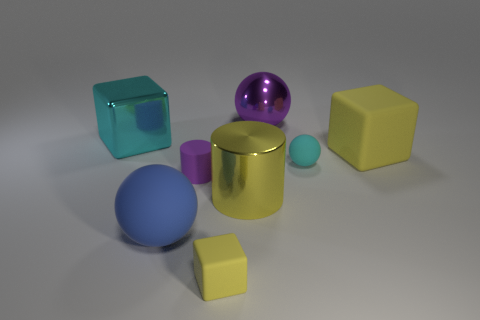How many objects are rubber cylinders or tiny yellow things left of the large yellow metallic cylinder?
Your response must be concise. 2. Do the small yellow cube and the blue thing have the same material?
Provide a succinct answer. Yes. How many other things are there of the same shape as the big cyan object?
Make the answer very short. 2. How big is the rubber object that is both behind the blue thing and in front of the tiny ball?
Offer a terse response. Small. What number of metal things are either big blue balls or big cyan objects?
Keep it short and to the point. 1. There is a large matte object that is on the left side of the metal ball; is its shape the same as the purple object left of the small matte cube?
Offer a very short reply. No. Is there a large sphere that has the same material as the tiny cyan thing?
Keep it short and to the point. Yes. What color is the small rubber block?
Provide a short and direct response. Yellow. What size is the yellow matte thing that is on the left side of the large yellow metallic cylinder?
Make the answer very short. Small. How many shiny spheres are the same color as the big matte sphere?
Offer a very short reply. 0. 